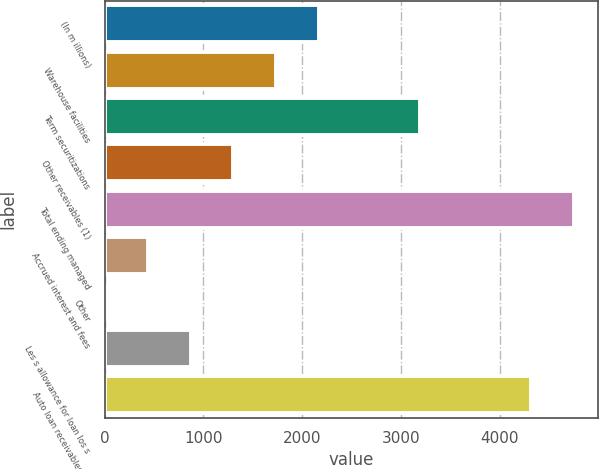<chart> <loc_0><loc_0><loc_500><loc_500><bar_chart><fcel>(In m illions)<fcel>Warehouse facilities<fcel>Term securitizations<fcel>Other receivables (1)<fcel>Total ending managed<fcel>Accrued interest and fees<fcel>Other<fcel>Les s allowance for loan los s<fcel>Auto loan receivables net<nl><fcel>2169.3<fcel>1736.24<fcel>3193.1<fcel>1303.18<fcel>4753.66<fcel>437.06<fcel>4<fcel>870.12<fcel>4320.6<nl></chart> 